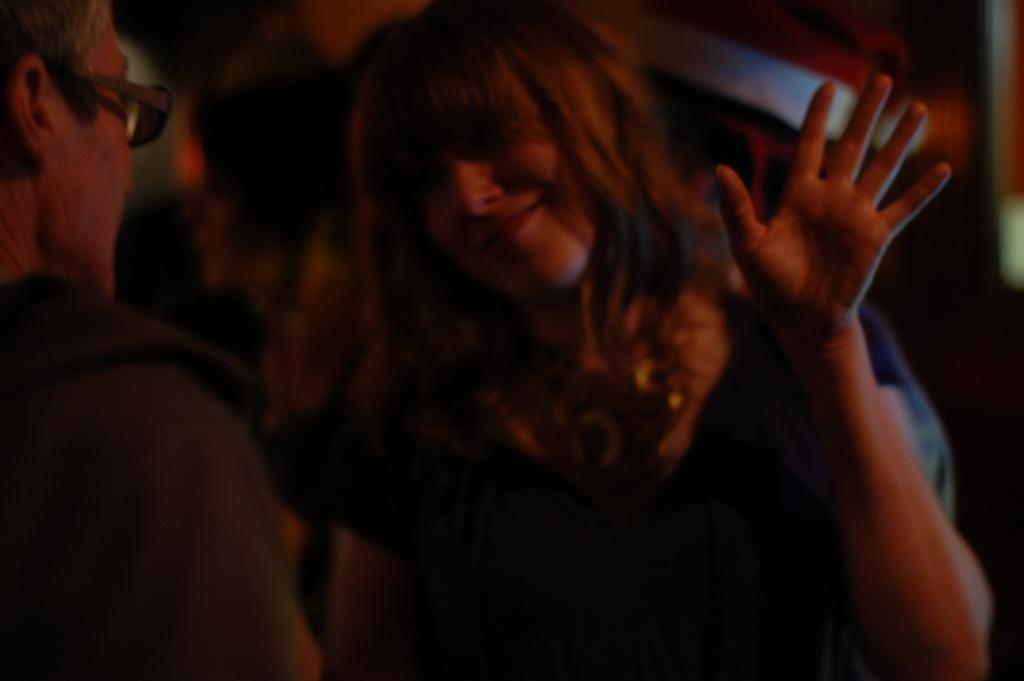Who is present in the image? There is a man and a woman in the image. What are the man and woman doing in the image? The man and woman are standing and looking at each other. What is the expression on the woman's face? The woman is smiling. What is the woman doing with her hand? The woman is showing her hand. How is the woman's hair styled in the image? The woman has loose hair. What type of lunch is the man eating in the image? There is no lunch present in the image; it features a man and a woman standing and looking at each other. Is there a carriage visible in the image? No, there is no carriage present in the image. 